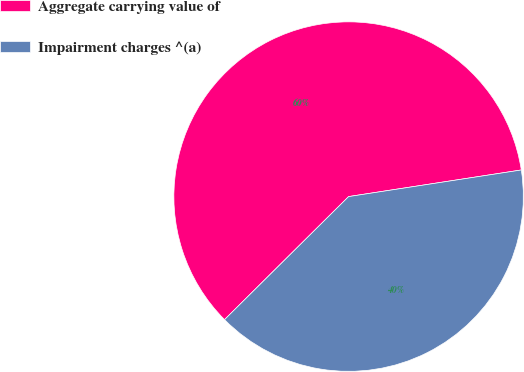Convert chart to OTSL. <chart><loc_0><loc_0><loc_500><loc_500><pie_chart><fcel>Aggregate carrying value of<fcel>Impairment charges ^(a)<nl><fcel>60.0%<fcel>40.0%<nl></chart> 